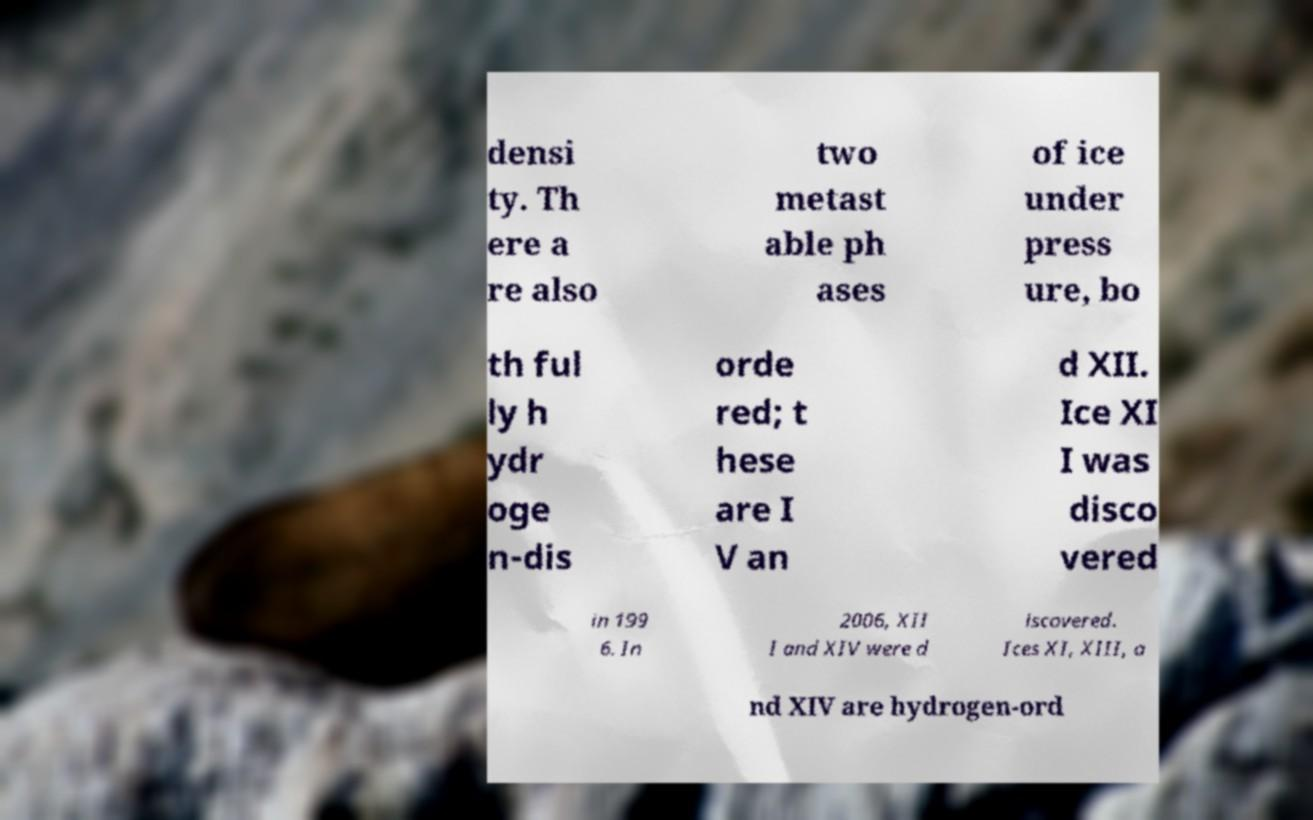Could you assist in decoding the text presented in this image and type it out clearly? densi ty. Th ere a re also two metast able ph ases of ice under press ure, bo th ful ly h ydr oge n-dis orde red; t hese are I V an d XII. Ice XI I was disco vered in 199 6. In 2006, XII I and XIV were d iscovered. Ices XI, XIII, a nd XIV are hydrogen-ord 